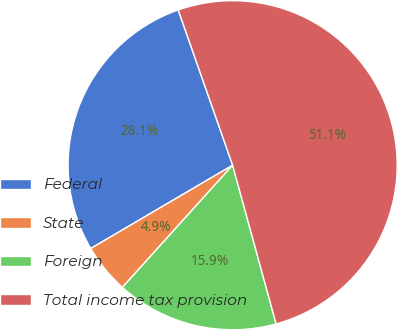<chart> <loc_0><loc_0><loc_500><loc_500><pie_chart><fcel>Federal<fcel>State<fcel>Foreign<fcel>Total income tax provision<nl><fcel>28.08%<fcel>4.87%<fcel>15.94%<fcel>51.11%<nl></chart> 